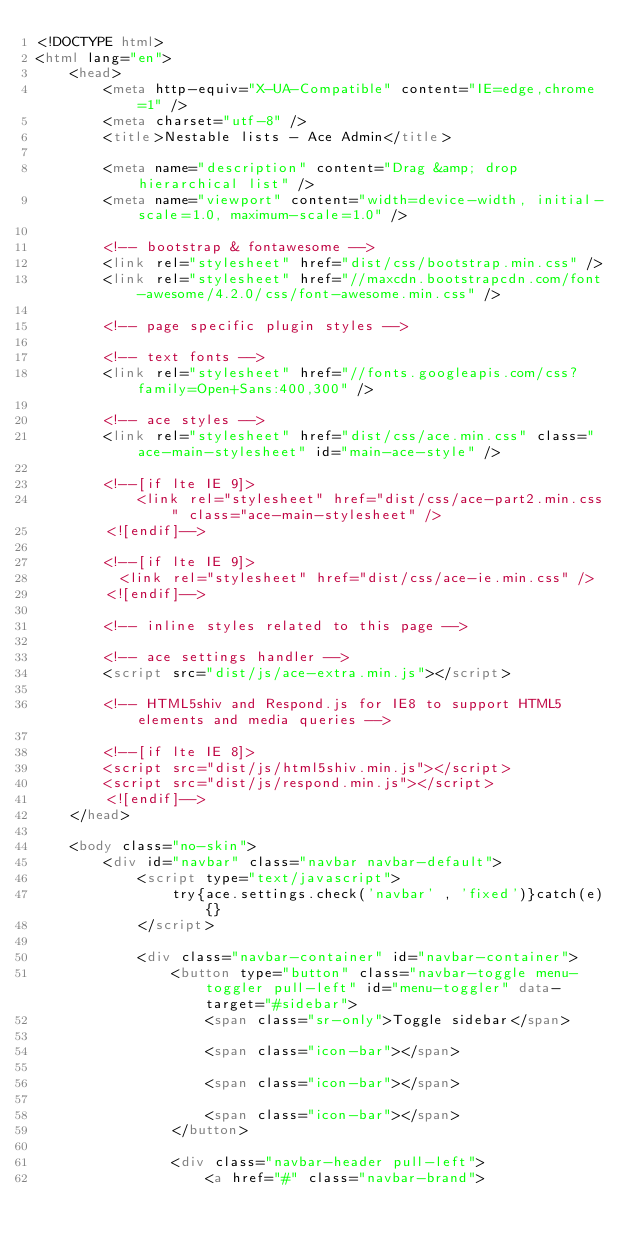Convert code to text. <code><loc_0><loc_0><loc_500><loc_500><_HTML_><!DOCTYPE html>
<html lang="en">
	<head>
		<meta http-equiv="X-UA-Compatible" content="IE=edge,chrome=1" />
		<meta charset="utf-8" />
		<title>Nestable lists - Ace Admin</title>

		<meta name="description" content="Drag &amp; drop hierarchical list" />
		<meta name="viewport" content="width=device-width, initial-scale=1.0, maximum-scale=1.0" />

		<!-- bootstrap & fontawesome -->
		<link rel="stylesheet" href="dist/css/bootstrap.min.css" />
		<link rel="stylesheet" href="//maxcdn.bootstrapcdn.com/font-awesome/4.2.0/css/font-awesome.min.css" />

		<!-- page specific plugin styles -->

		<!-- text fonts -->
		<link rel="stylesheet" href="//fonts.googleapis.com/css?family=Open+Sans:400,300" />

		<!-- ace styles -->
		<link rel="stylesheet" href="dist/css/ace.min.css" class="ace-main-stylesheet" id="main-ace-style" />

		<!--[if lte IE 9]>
			<link rel="stylesheet" href="dist/css/ace-part2.min.css" class="ace-main-stylesheet" />
		<![endif]-->

		<!--[if lte IE 9]>
		  <link rel="stylesheet" href="dist/css/ace-ie.min.css" />
		<![endif]-->

		<!-- inline styles related to this page -->

		<!-- ace settings handler -->
		<script src="dist/js/ace-extra.min.js"></script>

		<!-- HTML5shiv and Respond.js for IE8 to support HTML5 elements and media queries -->

		<!--[if lte IE 8]>
		<script src="dist/js/html5shiv.min.js"></script>
		<script src="dist/js/respond.min.js"></script>
		<![endif]-->
	</head>

	<body class="no-skin">
		<div id="navbar" class="navbar navbar-default">
			<script type="text/javascript">
				try{ace.settings.check('navbar' , 'fixed')}catch(e){}
			</script>

			<div class="navbar-container" id="navbar-container">
				<button type="button" class="navbar-toggle menu-toggler pull-left" id="menu-toggler" data-target="#sidebar">
					<span class="sr-only">Toggle sidebar</span>

					<span class="icon-bar"></span>

					<span class="icon-bar"></span>

					<span class="icon-bar"></span>
				</button>

				<div class="navbar-header pull-left">
					<a href="#" class="navbar-brand"></code> 